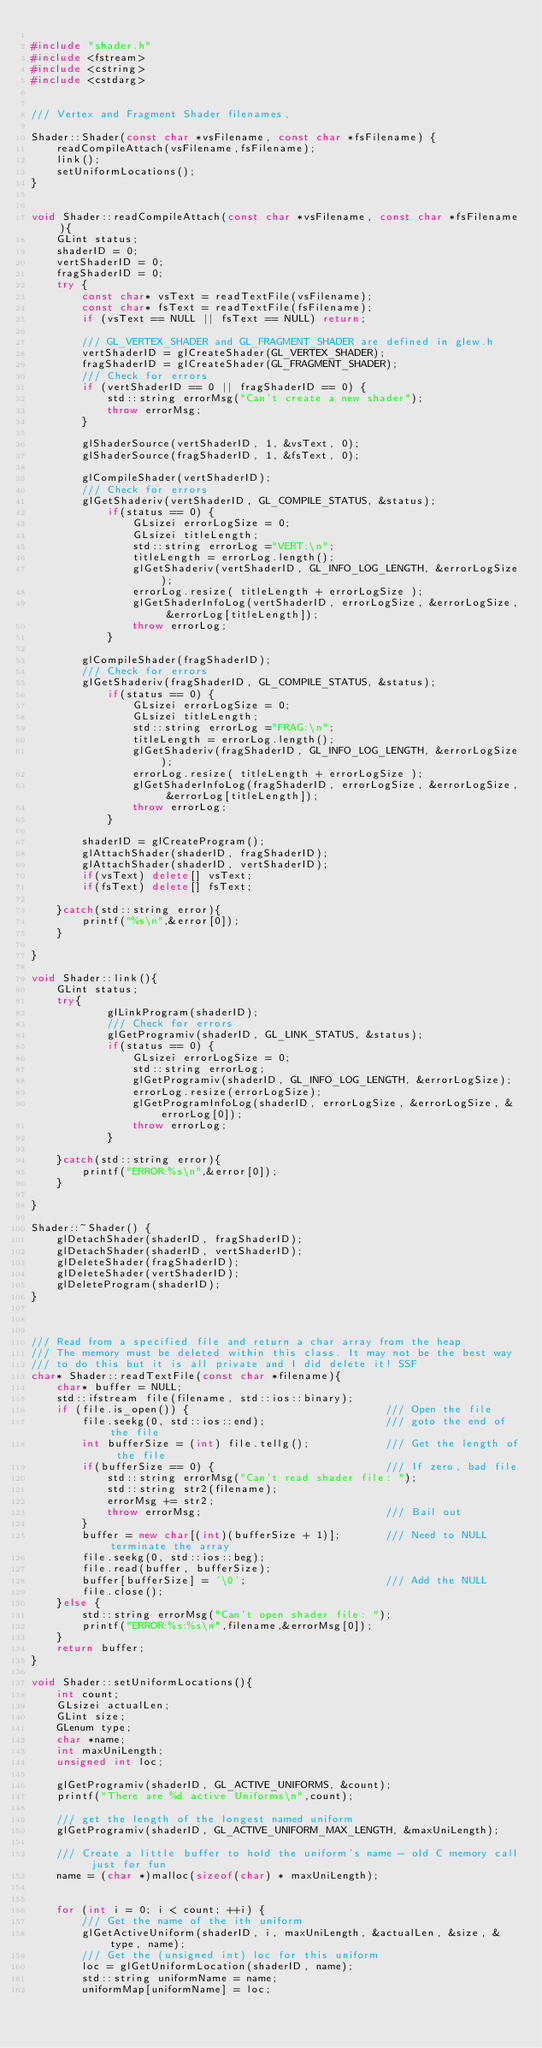<code> <loc_0><loc_0><loc_500><loc_500><_C++_>
#include "shader.h"
#include <fstream>
#include <cstring>
#include <cstdarg>


/// Vertex and Fragment Shader filenames,

Shader::Shader(const char *vsFilename, const char *fsFilename) {
	readCompileAttach(vsFilename,fsFilename);
	link();
	setUniformLocations();
}


void Shader::readCompileAttach(const char *vsFilename, const char *fsFilename){
    GLint status;
	shaderID = 0;
	vertShaderID = 0;
	fragShaderID = 0;
	try { 		
		const char* vsText = readTextFile(vsFilename);
		const char* fsText = readTextFile(fsFilename);
		if (vsText == NULL || fsText == NULL) return;

		/// GL_VERTEX_SHADER and GL_FRAGMENT_SHADER are defined in glew.h
		vertShaderID = glCreateShader(GL_VERTEX_SHADER);
		fragShaderID = glCreateShader(GL_FRAGMENT_SHADER);
		/// Check for errors
		if (vertShaderID == 0 || fragShaderID == 0) {
			std::string errorMsg("Can't create a new shader");
			throw errorMsg;
		}
    
		glShaderSource(vertShaderID, 1, &vsText, 0);   
		glShaderSource(fragShaderID, 1, &fsText, 0);
    
		glCompileShader(vertShaderID);
		/// Check for errors
		glGetShaderiv(vertShaderID, GL_COMPILE_STATUS, &status);
			if(status == 0) {
				GLsizei errorLogSize = 0;
				GLsizei titleLength;
				std::string errorLog ="VERT:\n";
				titleLength = errorLog.length();
				glGetShaderiv(vertShaderID, GL_INFO_LOG_LENGTH, &errorLogSize);
				errorLog.resize( titleLength + errorLogSize );
				glGetShaderInfoLog(vertShaderID, errorLogSize, &errorLogSize, &errorLog[titleLength]);
				throw errorLog;
			}

		glCompileShader(fragShaderID);
		/// Check for errors
		glGetShaderiv(fragShaderID, GL_COMPILE_STATUS, &status);
			if(status == 0) {
				GLsizei errorLogSize = 0;
				GLsizei titleLength;
				std::string errorLog ="FRAG:\n";
				titleLength = errorLog.length();
				glGetShaderiv(fragShaderID, GL_INFO_LOG_LENGTH, &errorLogSize);
				errorLog.resize( titleLength + errorLogSize );
				glGetShaderInfoLog(fragShaderID, errorLogSize, &errorLogSize, &errorLog[titleLength]);
				throw errorLog;
			}
    
		shaderID = glCreateProgram();
		glAttachShader(shaderID, fragShaderID);
		glAttachShader(shaderID, vertShaderID);
		if(vsText) delete[] vsText;
		if(fsText) delete[] fsText;

	}catch(std::string error){
		printf("%s\n",&error[0]);
	}
	 
}

void Shader::link(){
	GLint status;
	try{
			glLinkProgram(shaderID);
			/// Check for errors
			glGetProgramiv(shaderID, GL_LINK_STATUS, &status);
			if(status == 0) {
				GLsizei errorLogSize = 0;
				std::string errorLog;
				glGetProgramiv(shaderID, GL_INFO_LOG_LENGTH, &errorLogSize);
				errorLog.resize(errorLogSize);
				glGetProgramInfoLog(shaderID, errorLogSize, &errorLogSize, &errorLog[0]);
				throw errorLog;
			}
		
	}catch(std::string error){
		printf("ERROR:%s\n",&error[0]);
	}

}

Shader::~Shader() {
	glDetachShader(shaderID, fragShaderID);
	glDetachShader(shaderID, vertShaderID);  
	glDeleteShader(fragShaderID);
	glDeleteShader(vertShaderID);
	glDeleteProgram(shaderID);
}



/// Read from a specified file and return a char array from the heap 
/// The memory must be deleted within this class. It may not be the best way 
/// to do this but it is all private and I did delete it! SSF
char* Shader::readTextFile(const char *filename){
	char* buffer = NULL;
    std::ifstream file(filename, std::ios::binary);
    if (file.is_open()) {								/// Open the file
        file.seekg(0, std::ios::end);					/// goto the end of the file
        int bufferSize = (int) file.tellg();			/// Get the length of the file
		if(bufferSize == 0) {							/// If zero, bad file
			std::string errorMsg("Can't read shader file: ");
			std::string str2(filename);
			errorMsg += str2;
			throw errorMsg;								/// Bail out
		}
		buffer = new char[(int)(bufferSize + 1)];		/// Need to NULL terminate the array
        file.seekg(0, std::ios::beg);
        file.read(buffer, bufferSize);
		buffer[bufferSize] = '\0';						/// Add the NULL
		file.close();
    }else { 
		std::string errorMsg("Can't open shader file: ");
		printf("ERROR:%s:%s\n",filename,&errorMsg[0]);
	}
	return buffer;
}

void Shader::setUniformLocations(){
	int count;
	GLsizei actualLen;
	GLint size;
	GLenum type;
	char *name;
	int maxUniLength;
	unsigned int loc;

	glGetProgramiv(shaderID, GL_ACTIVE_UNIFORMS, &count);
	printf("There are %d active Uniforms\n",count);

	/// get the length of the longest named uniform 
	glGetProgramiv(shaderID, GL_ACTIVE_UNIFORM_MAX_LENGTH, &maxUniLength);

	/// Create a little buffer to hold the uniform's name - old C memory call just for fun 
	name = (char *)malloc(sizeof(char) * maxUniLength);

	
	for (int i = 0; i < count; ++i) {
		/// Get the name of the ith uniform
		glGetActiveUniform(shaderID, i, maxUniLength, &actualLen, &size, &type, name);
		/// Get the (unsigned int) loc for this uniform
		loc = glGetUniformLocation(shaderID, name);
		std::string uniformName = name;
		uniformMap[uniformName] = loc;
</code> 